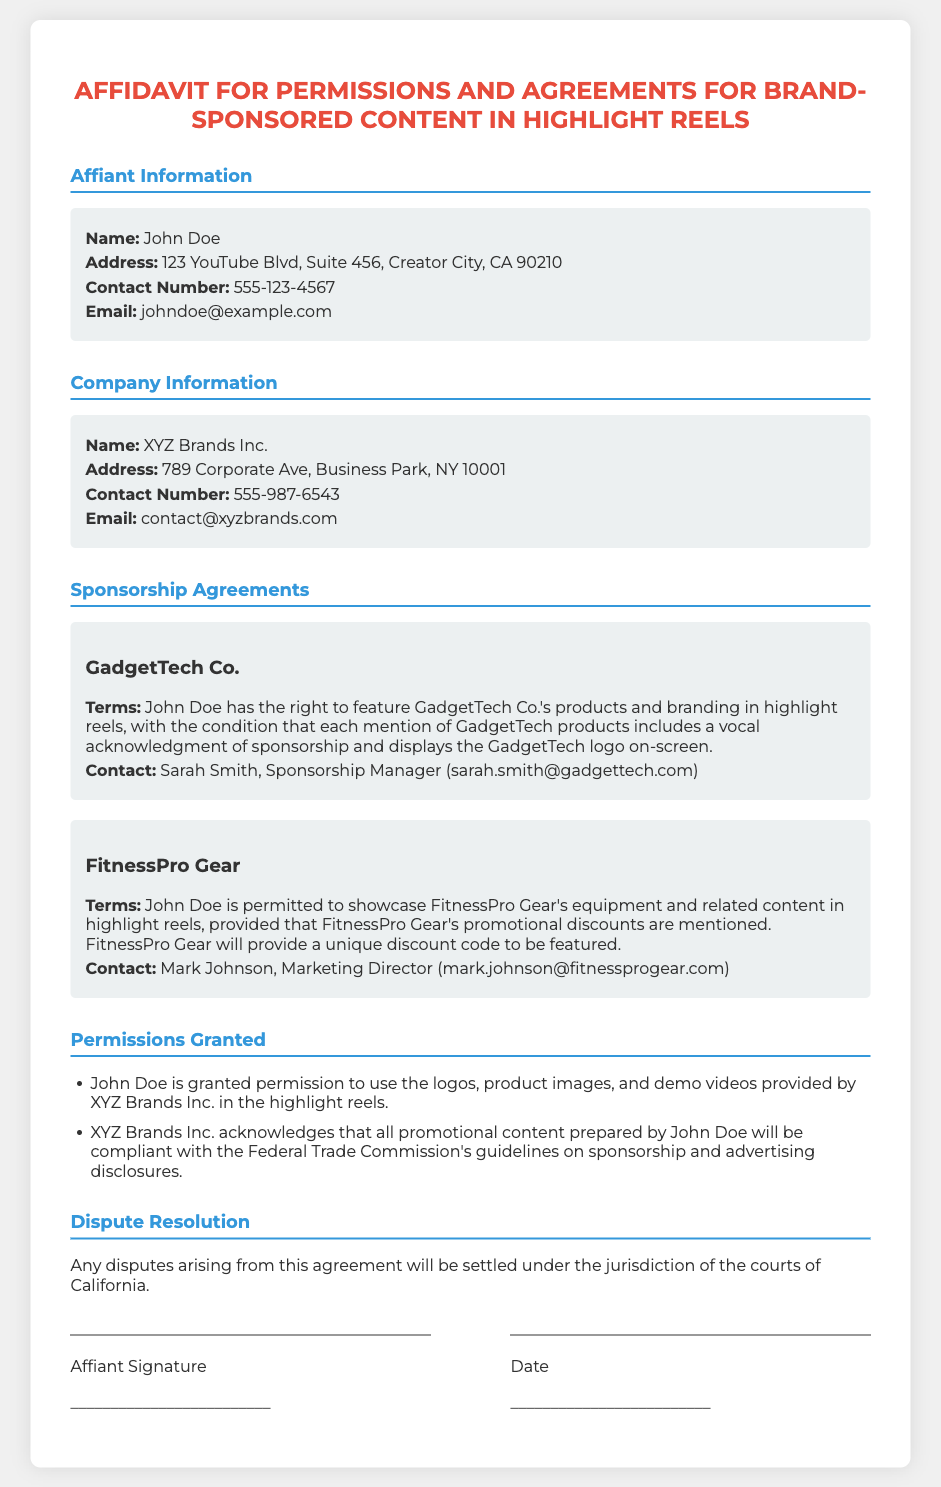what is the name of the affiant? The affiant's name is provided in the Affiant Information section of the document.
Answer: John Doe what is the contact number for XYZ Brands Inc.? The document includes specific contact details for XYZ Brands Inc.
Answer: 555-987-6543 who is the Marketing Director for FitnessPro Gear? This role is mentioned under the sponsorship agreements for FitnessPro Gear.
Answer: Mark Johnson what are the terms for showcasing GadgetTech Co.'s products? The terms outline specific conditions that must be followed while showcasing these products.
Answer: Vocal acknowledgment of sponsorship and displays the GadgetTech logo on-screen what is the email address for the Sponsorship Manager at GadgetTech Co.? This information is specified in the contact details for GadgetTech Co.
Answer: sarah.smith@gadgettech.com which state is mentioned for dispute resolution? The document specifies the jurisdiction for disputes within a particular location.
Answer: California how many companies are mentioned in the sponsorship agreements? The section details multiple companies involved in the sponsorship agreements.
Answer: 2 what unique feature is required in the highlight reels for FitnessPro Gear? This refers to the specific promotional element that must be included as per the agreement.
Answer: Unique discount code what should promotional content comply with? The document emphasizes compliance with specific guidelines for promotional content.
Answer: Federal Trade Commission's guidelines 